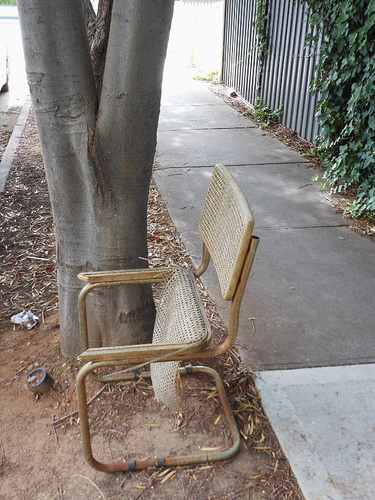<image>
Can you confirm if the chair is under the tree? No. The chair is not positioned under the tree. The vertical relationship between these objects is different. Is there a tree next to the chair? Yes. The tree is positioned adjacent to the chair, located nearby in the same general area. 